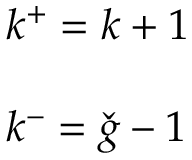Convert formula to latex. <formula><loc_0><loc_0><loc_500><loc_500>\begin{array} { l } { { k ^ { + } = k + 1 } } \\ { \ } \\ { { k ^ { - } = \check { g } - 1 } } \end{array}</formula> 